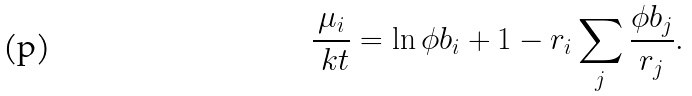<formula> <loc_0><loc_0><loc_500><loc_500>\frac { \mu _ { i } } { \ k t } = \ln \phi b _ { i } + 1 - r _ { i } \sum _ { j } \frac { \phi b _ { j } } { r _ { j } } .</formula> 